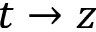<formula> <loc_0><loc_0><loc_500><loc_500>t \to z</formula> 